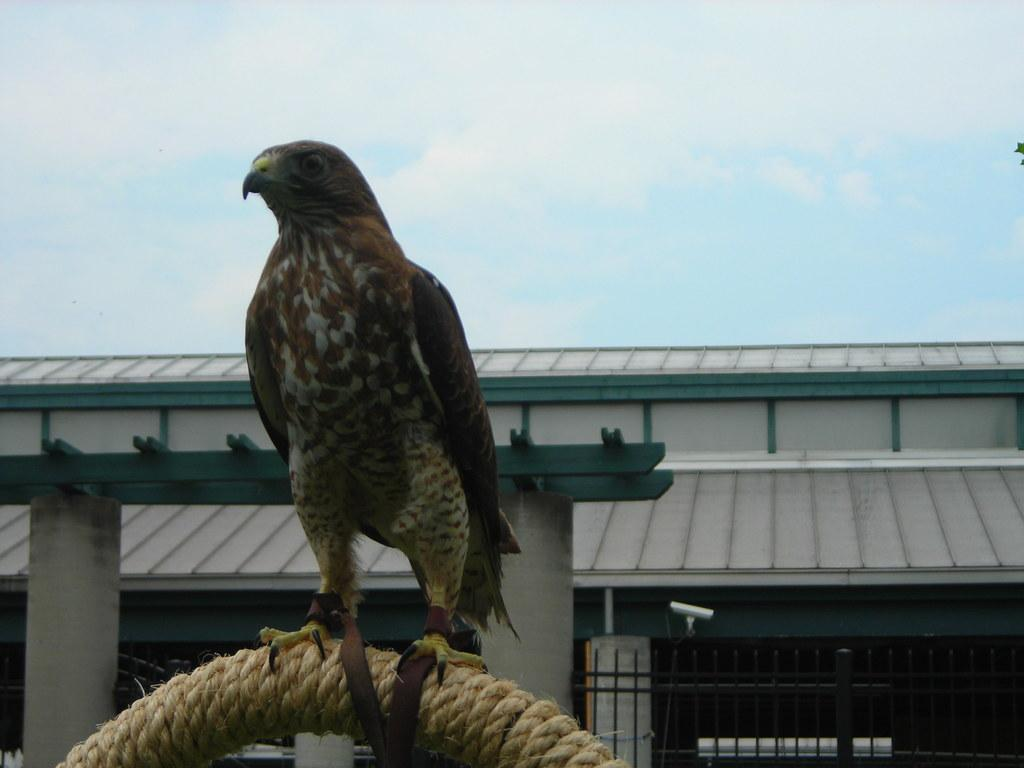What animal is the main subject of the image? There is an eagle in the image. What is the eagle standing on? The eagle is standing on a rope. What can be seen in the background of the image? There is a building visible in the background of the image. What is visible in the sky in the image? The sky is visible in the image, and clouds are present in the sky. What is on the right side of the image? There is a leaf on the right side of the image. How many jellyfish can be seen swimming in the image? There are no jellyfish present in the image; it features an eagle standing on a rope. What type of yarn is the eagle using to create a knitted scarf in the image? There is no yarn or knitting activity depicted in the image; the eagle is simply standing on a rope. 